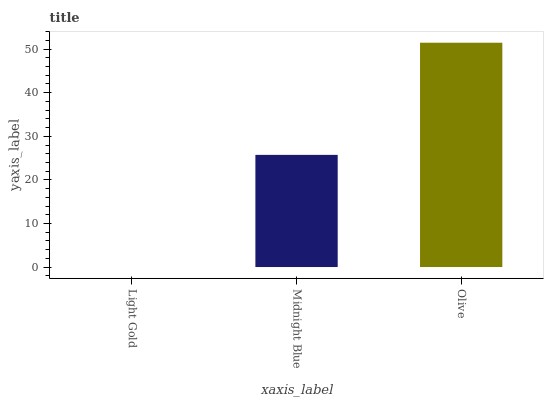Is Midnight Blue the minimum?
Answer yes or no. No. Is Midnight Blue the maximum?
Answer yes or no. No. Is Midnight Blue greater than Light Gold?
Answer yes or no. Yes. Is Light Gold less than Midnight Blue?
Answer yes or no. Yes. Is Light Gold greater than Midnight Blue?
Answer yes or no. No. Is Midnight Blue less than Light Gold?
Answer yes or no. No. Is Midnight Blue the high median?
Answer yes or no. Yes. Is Midnight Blue the low median?
Answer yes or no. Yes. Is Light Gold the high median?
Answer yes or no. No. Is Olive the low median?
Answer yes or no. No. 